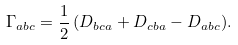Convert formula to latex. <formula><loc_0><loc_0><loc_500><loc_500>\Gamma _ { a b c } = \frac { 1 } { 2 } \, ( D _ { b c a } + D _ { c b a } - D _ { a b c } ) .</formula> 